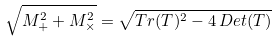<formula> <loc_0><loc_0><loc_500><loc_500>\sqrt { M _ { + } ^ { 2 } + M _ { \times } ^ { 2 } } = \sqrt { T r ( T ) ^ { 2 } - 4 \, D e t ( T ) } \,</formula> 